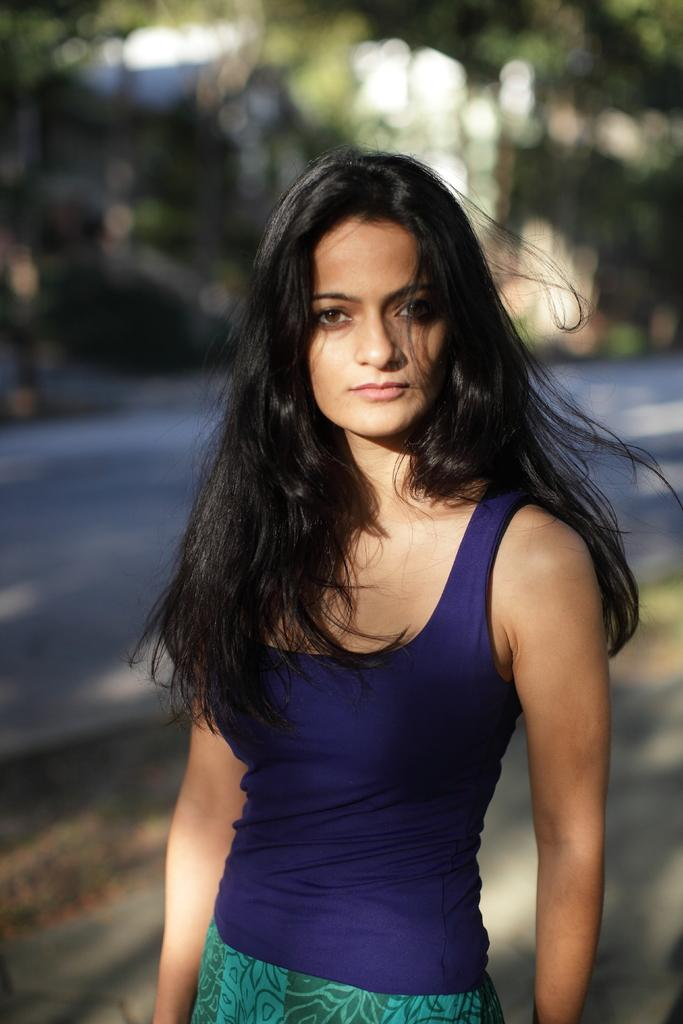What is the main subject of the image? The main subject of the image is a woman. What is the woman wearing in the image? The woman is wearing a blue color bani yin. What is the woman's position in the image? The woman is standing on the floor. Can you see any growth or plants near the lake in the image? There is no lake present in the image, so it's not possible to determine if there are any growth or plants near it. 